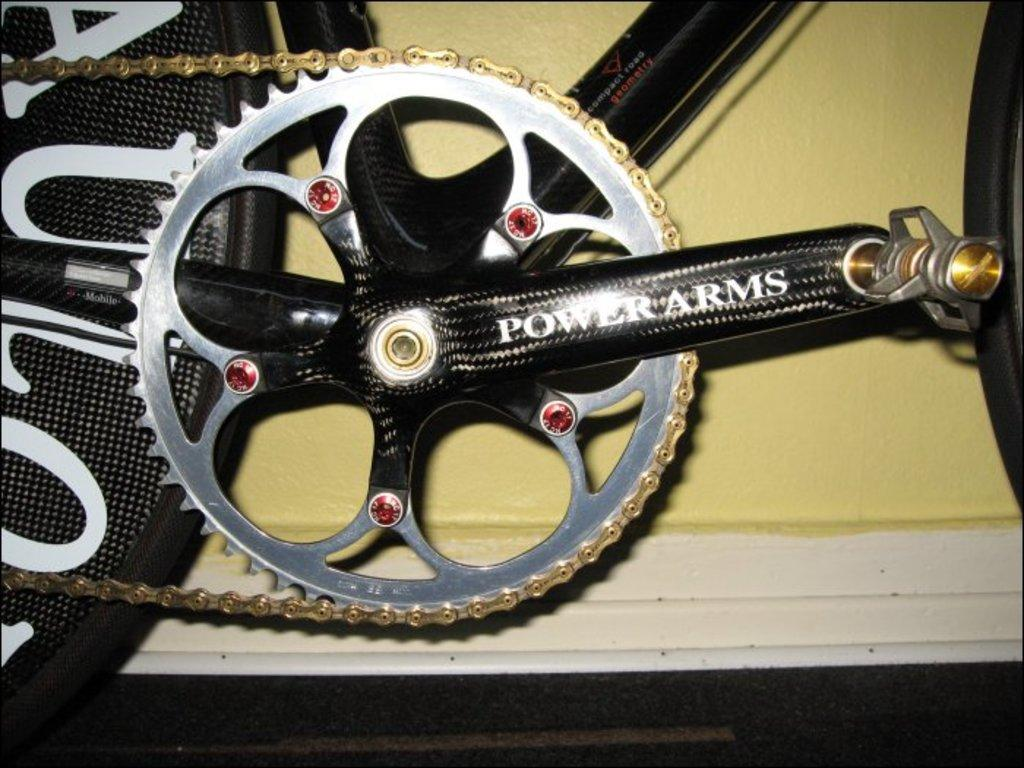What is the main subject of the picture? The main subject of the picture is a bicycle. What is the color of the bicycle's frame? The bicycle has a black color frame. What is a part of the bicycle that helps it move? The bicycle has a chain. What can be seen on the wheel of the bicycle? There is something written on the wheel of the bicycle. What is visible in the background of the picture? There is a wall in the background of the picture. How does the beef increase in size while riding the bicycle in the image? There is no beef present in the image, and the bicycle rider's size does not change in the image. What type of tail can be seen on the bicycle in the image? There is no tail present on the bicycle in the image. 